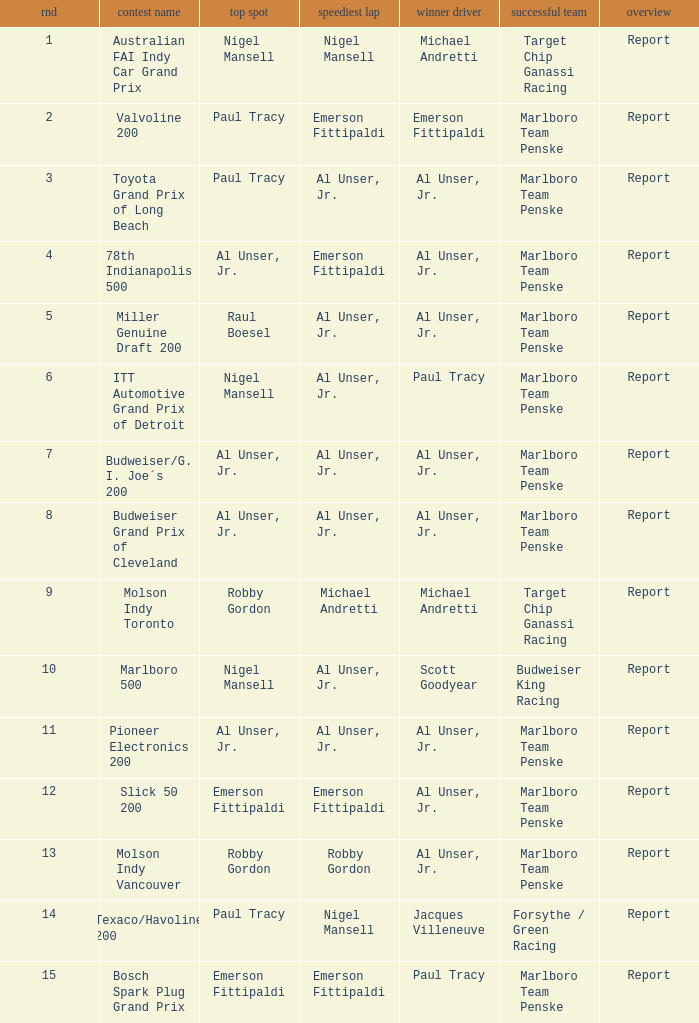Who was at the pole position in the ITT Automotive Grand Prix of Detroit, won by Paul Tracy? Nigel Mansell. 